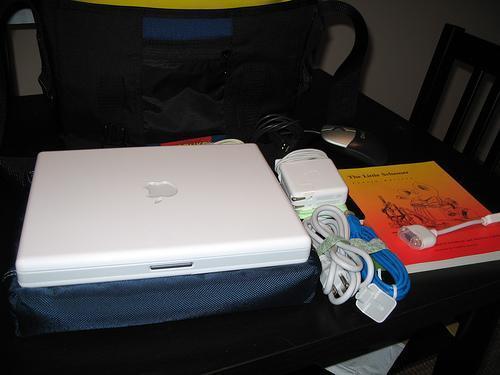How many laptops are visible?
Give a very brief answer. 1. 